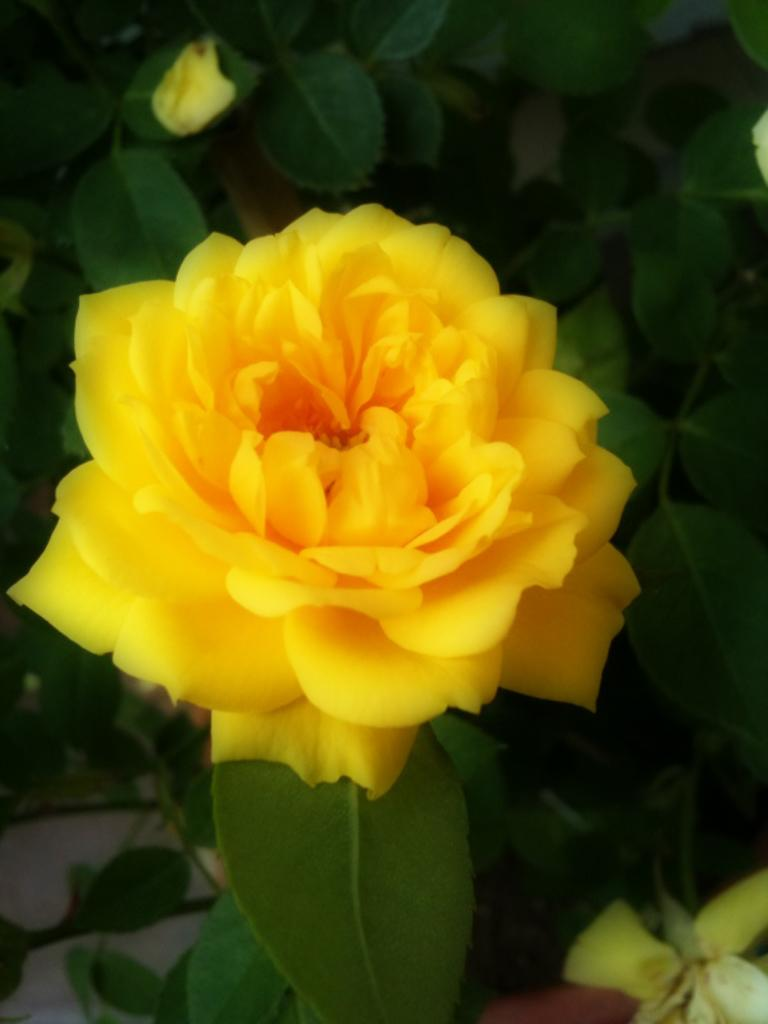What is present in the image? There is a plant in the image. What can be observed about the plant's flower? The plant has a yellow flower. What type of cabbage is growing in the room in the image? There is no cabbage present in the image, and the image does not depict a room. 